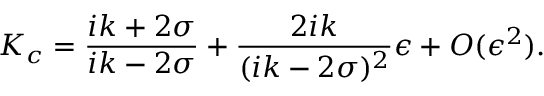Convert formula to latex. <formula><loc_0><loc_0><loc_500><loc_500>K _ { c } = \frac { i k + 2 \sigma } { i k - 2 \sigma } + \frac { 2 i k } { ( i k - 2 \sigma ) ^ { 2 } } \epsilon + O ( \epsilon ^ { 2 } ) .</formula> 